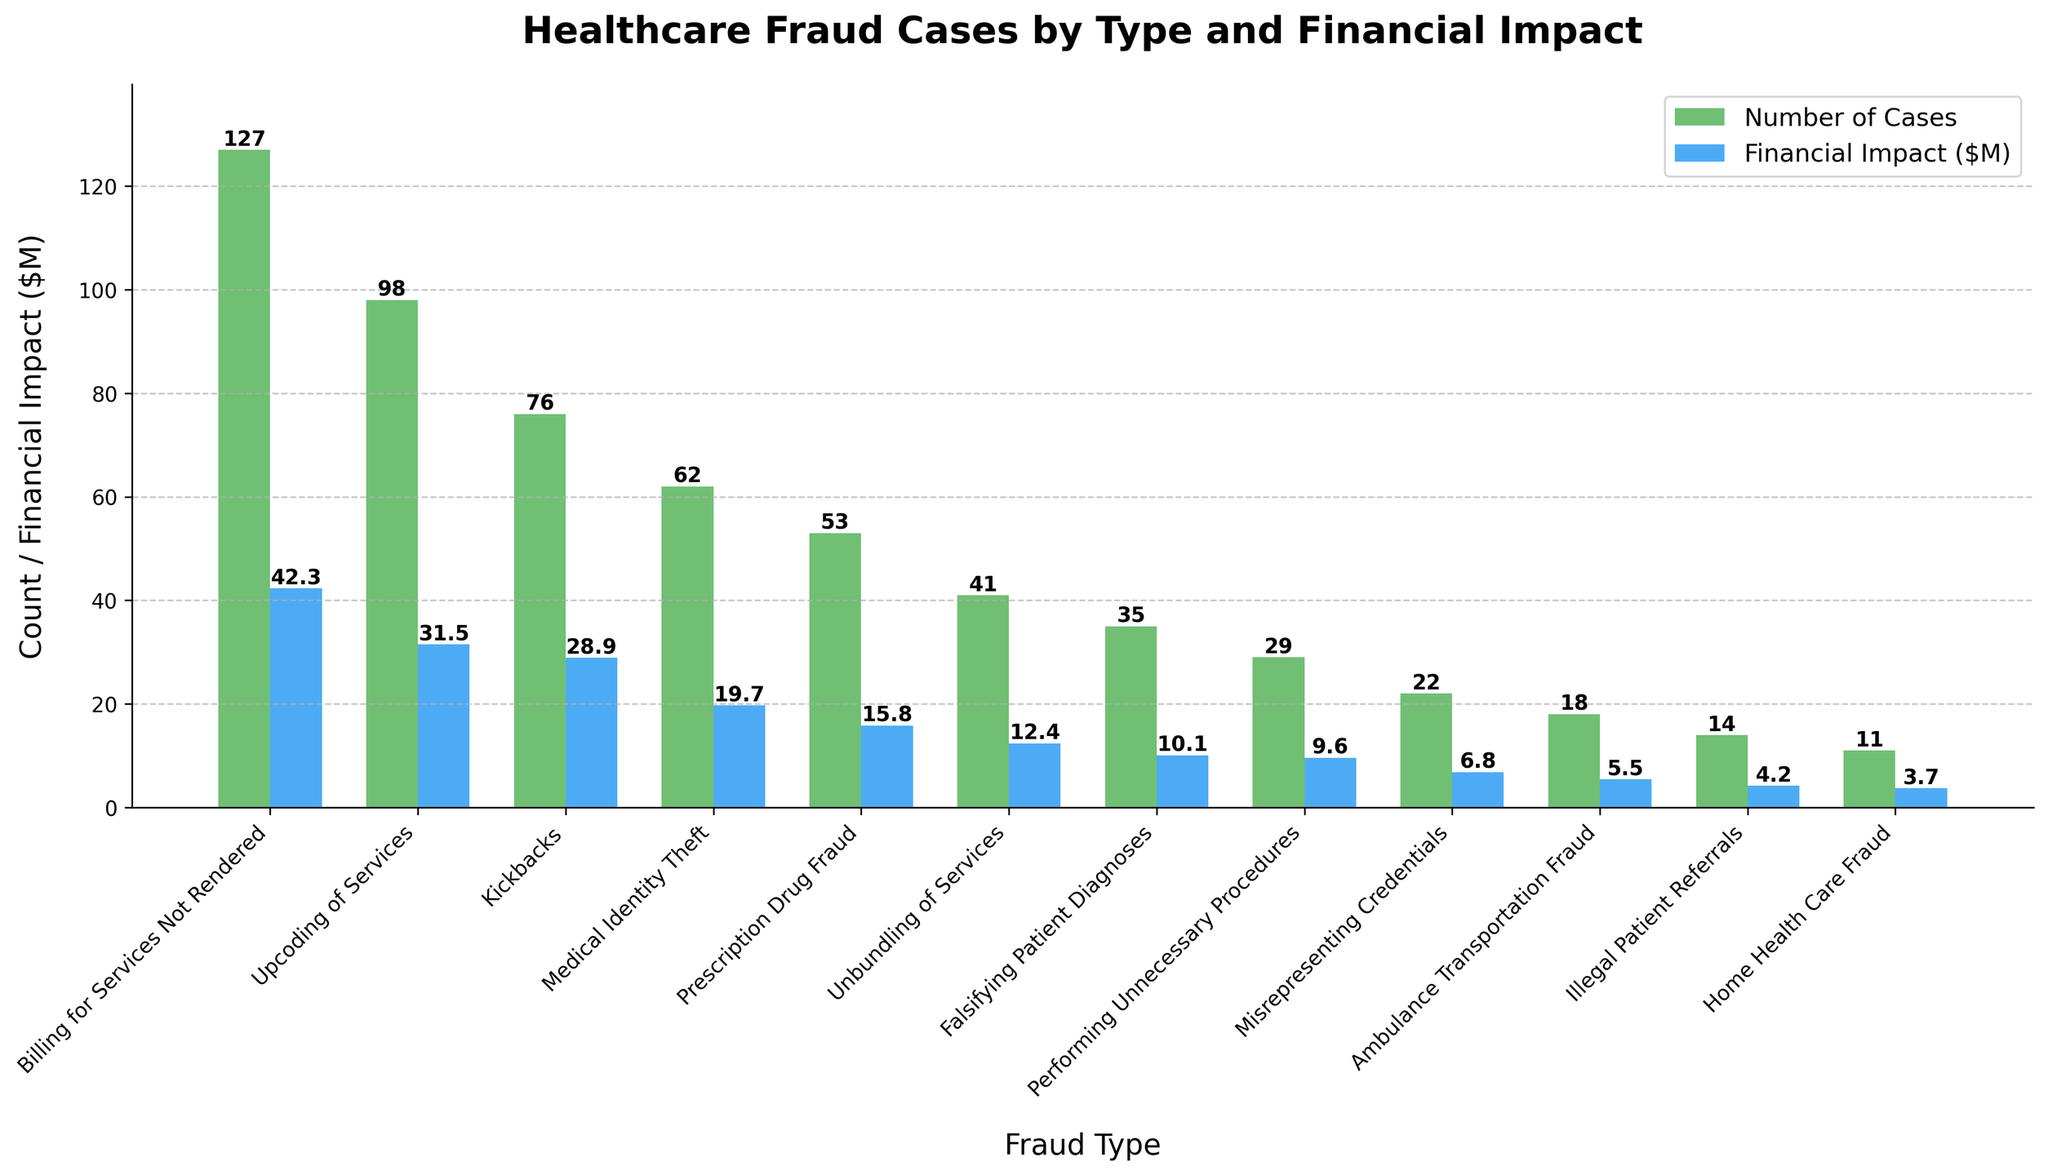What is the most common type of healthcare fraud in terms of the number of cases? The most common type is the one with the tallest green bar representing the 'Number of Cases'. 'Billing for Services Not Rendered' has the highest number of cases (127), as shown by its tallest green bar.
Answer: Billing for Services Not Rendered Which fraud type has the highest financial impact in million dollars? The fraud type with the highest financial impact will be the one with the tallest blue bar representing 'Financial Impact ($M)'. 'Billing for Services Not Rendered' has the highest financial impact of $42.3 million.
Answer: Billing for Services Not Rendered What is the total number of cases for 'Medical Identity Theft' and 'Prescription Drug Fraud'? Add the number of cases for 'Medical Identity Theft' (62) and 'Prescription Drug Fraud' (53). The sum is 62 + 53 = 115.
Answer: 115 Which fraud type has a larger financial impact: 'Kickbacks' or 'Medical Identity Theft'? Compare the financial impact of 'Kickbacks' ($28.9M) and 'Medical Identity Theft' ($19.7M). 'Kickbacks' has a larger financial impact.
Answer: Kickbacks What is the difference in financial impact between 'Upcoding of Services' and 'Falsifying Patient Diagnoses'? Subtract the financial impact of 'Falsifying Patient Diagnoses' ($10.1M) from 'Upcoding of Services' ($31.5M). The difference is 31.5 - 10.1 = 21.4 million dollars.
Answer: $21.4M Which fraud type has the fewest cases, and what is its financial impact? Identify the smallest green bar for the 'Number of Cases', which is for 'Home Health Care Fraud' with 11 cases. Its blue bar shows a financial impact of $3.7 million.
Answer: Home Health Care Fraud, $3.7M Identify the fraud type where the number of cases is closest to 30 cases and specify its financial impact. The fraud type 'Performing Unnecessary Procedures' has 29 cases, which is closest to 30 cases. Its financial impact is $9.6 million.
Answer: Performing Unnecessary Procedures, $9.6M Compare the financial impact of 'Misrepresenting Credentials' with 'Ambulance Transportation Fraud'. Which has a higher value and by how much? 'Misrepresenting Credentials' has a financial impact of $6.8M and 'Ambulance Transportation Fraud' has a financial impact of $5.5M. The difference is 6.8 - 5.5 = $1.3M, with 'Misrepresenting Credentials' being higher.
Answer: Misrepresenting Credentials, $1.3M What is the average financial impact of 'Kickbacks', 'Upcoding of Services', and 'Medical Identity Theft'? Calculate the average of the financial impacts: (28.9 + 31.5 + 19.7) / 3 = 80.1 / 3 ≈ $26.7M.
Answer: $26.7M 